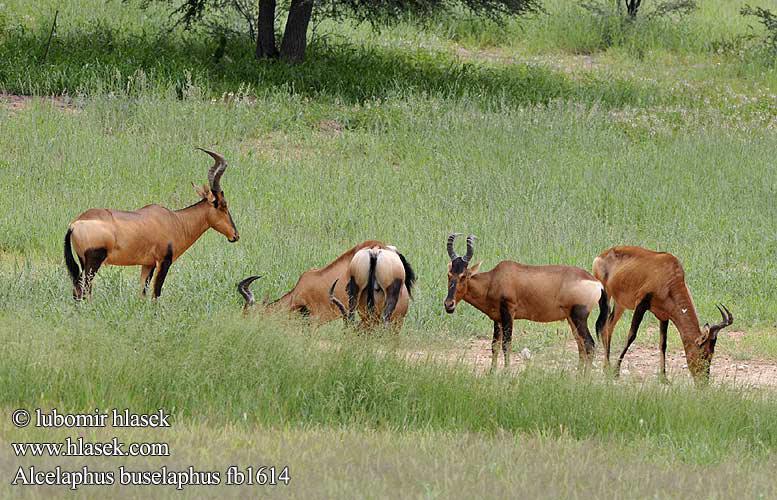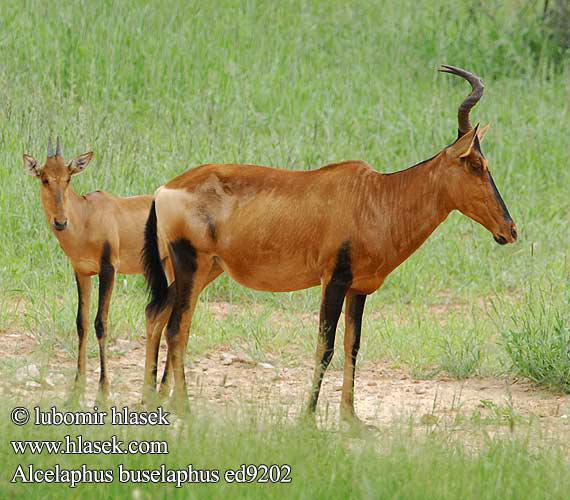The first image is the image on the left, the second image is the image on the right. Assess this claim about the two images: "The right image contains at least twice as many hooved animals as the left image.". Correct or not? Answer yes or no. No. The first image is the image on the left, the second image is the image on the right. Evaluate the accuracy of this statement regarding the images: "There is a grand total of 4 animals between both pictures.". Is it true? Answer yes or no. No. 